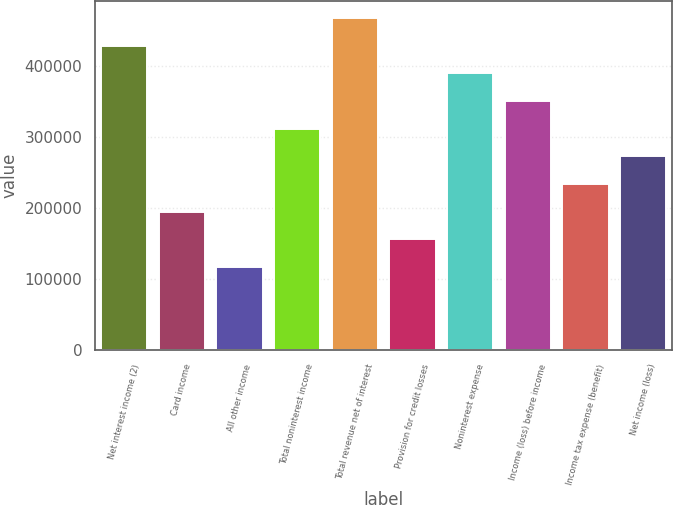<chart> <loc_0><loc_0><loc_500><loc_500><bar_chart><fcel>Net interest income (2)<fcel>Card income<fcel>All other income<fcel>Total noninterest income<fcel>Total revenue net of interest<fcel>Provision for credit losses<fcel>Noninterest expense<fcel>Income (loss) before income<fcel>Income tax expense (benefit)<fcel>Net income (loss)<nl><fcel>428395<fcel>194727<fcel>116837<fcel>311561<fcel>467339<fcel>155782<fcel>389450<fcel>350505<fcel>233671<fcel>272616<nl></chart> 